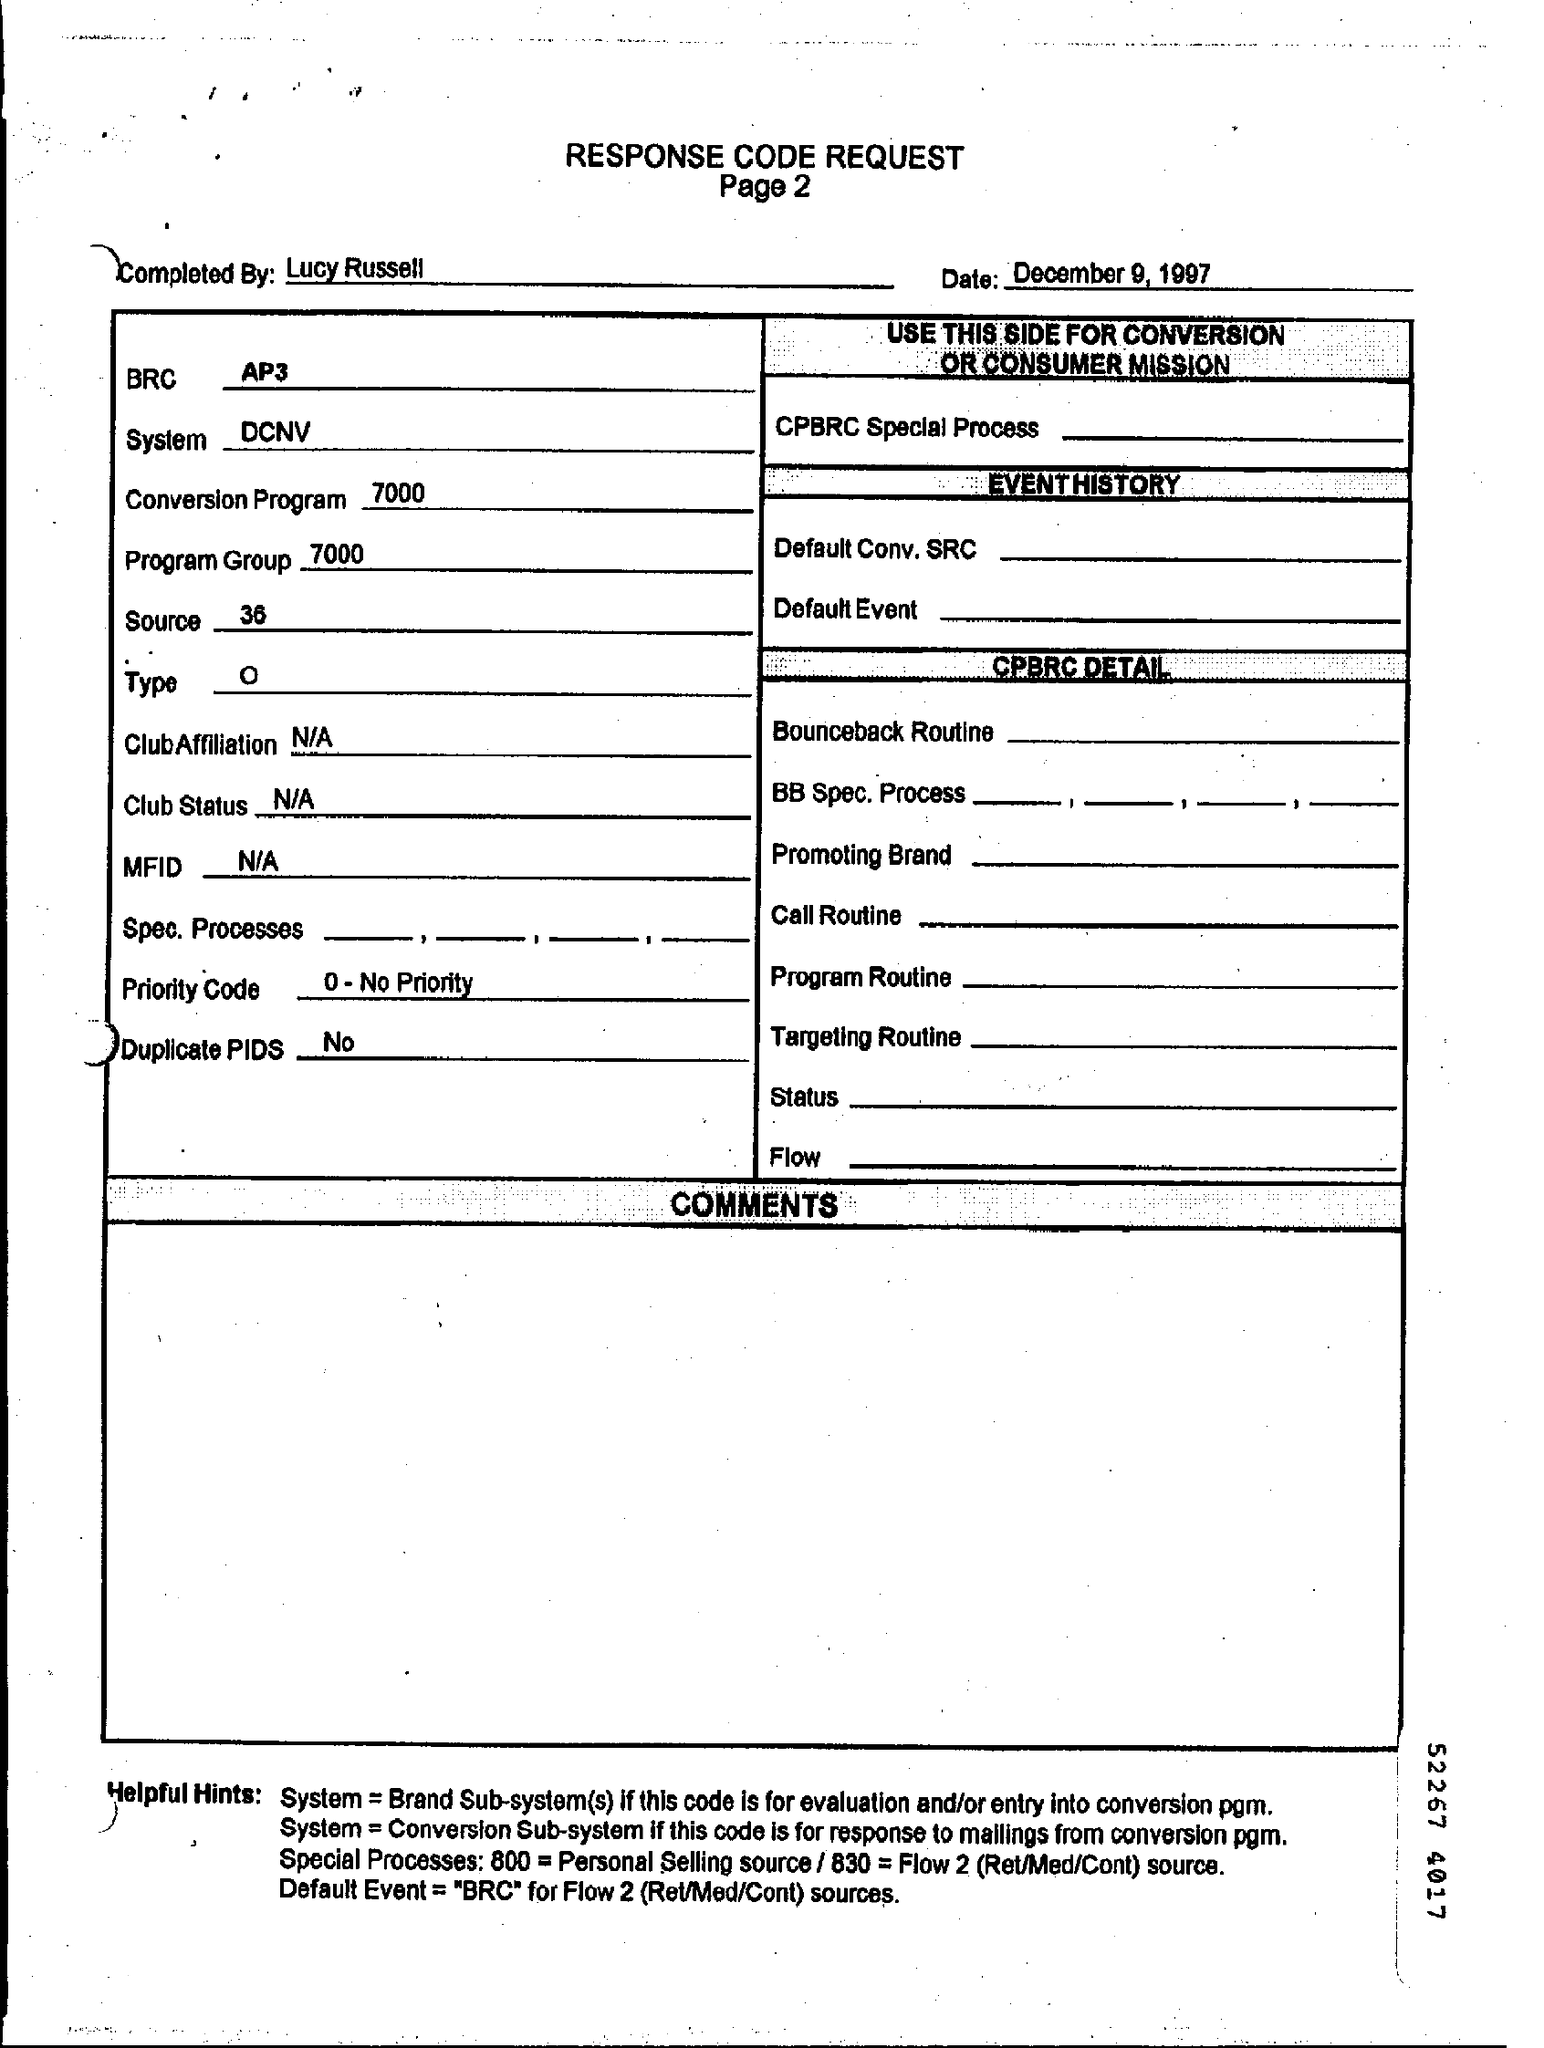What is no. of page?
Your answer should be compact. 2. Who completed the document?
Ensure brevity in your answer.  Lucy Russell. What is the date of the document?
Make the answer very short. December 9, 1997. What is date?
Offer a terse response. December 9, 1997. What is BRC?
Your response must be concise. AP3. What is source?
Give a very brief answer. 36. What is MFID?
Keep it short and to the point. N/A. What is Club Status?
Your answer should be compact. N/A. 